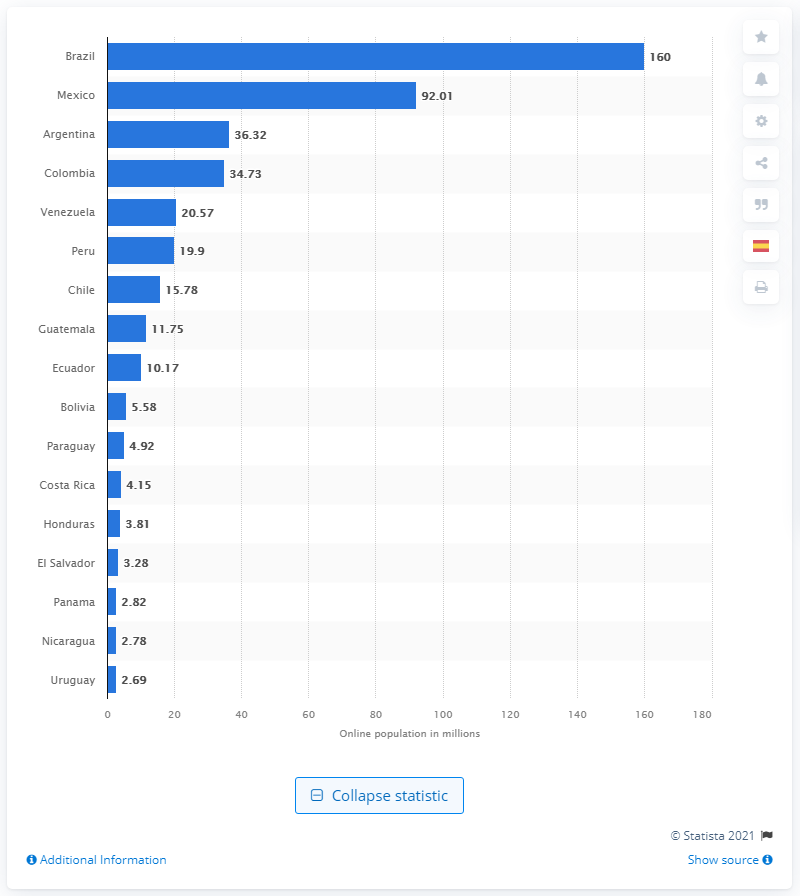Give some essential details in this illustration. As of January 2021, Brazil had approximately 160 million internet users. 